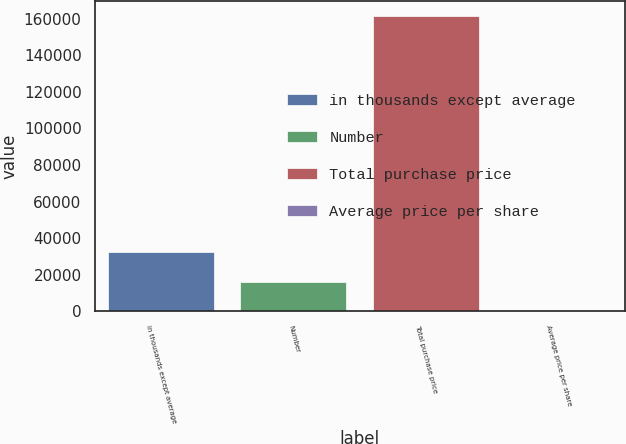Convert chart to OTSL. <chart><loc_0><loc_0><loc_500><loc_500><bar_chart><fcel>in thousands except average<fcel>Number<fcel>Total purchase price<fcel>Average price per share<nl><fcel>32383.1<fcel>16248.2<fcel>161463<fcel>113.18<nl></chart> 